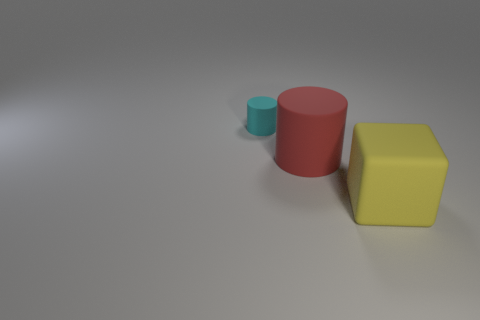Is there any other thing that has the same size as the cyan matte cylinder?
Your answer should be very brief. No. What size is the yellow cube?
Ensure brevity in your answer.  Large. How many other objects are the same material as the small object?
Offer a very short reply. 2. There is a rubber thing that is on the left side of the large yellow thing and right of the cyan cylinder; what is its size?
Your response must be concise. Large. What shape is the matte thing that is left of the large object to the left of the big yellow rubber object?
Your answer should be very brief. Cylinder. Are there any other things that are the same shape as the big yellow thing?
Offer a terse response. No. Is the number of tiny matte things behind the large red thing the same as the number of big red rubber cylinders?
Make the answer very short. Yes. The rubber object that is both left of the big yellow block and to the right of the small cyan rubber cylinder is what color?
Keep it short and to the point. Red. There is a big thing that is in front of the large rubber cylinder; what number of big red matte cylinders are behind it?
Ensure brevity in your answer.  1. Are there any cyan things that have the same shape as the red object?
Your answer should be very brief. Yes. 